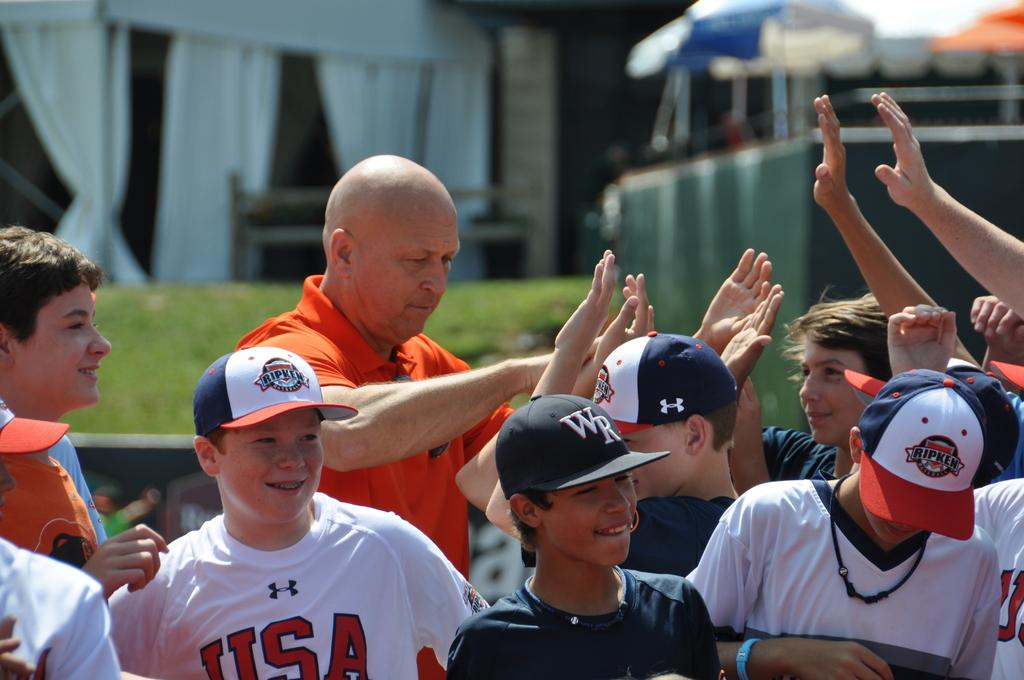<image>
Offer a succinct explanation of the picture presented. A group of kids wearing white tops with USA on them celebrate with their manager. 